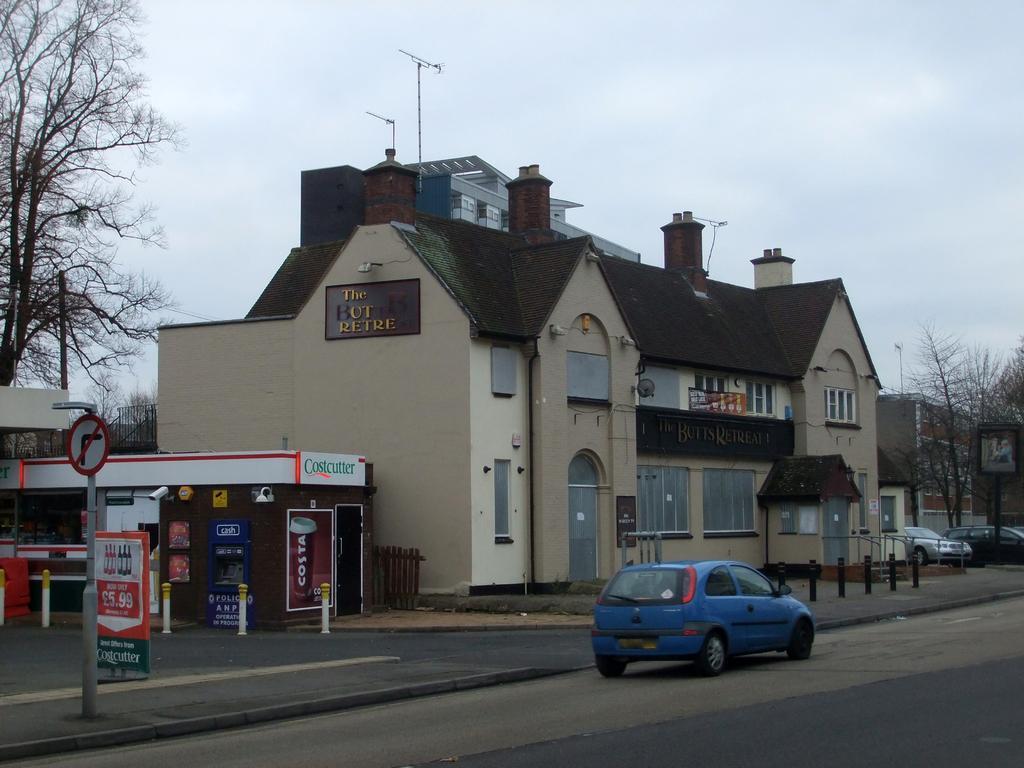Can you describe this image briefly? In this image I can see the road, few vehicles on the road, few poles, few boards, few trees and few buildings. In the background I can see the sky. 